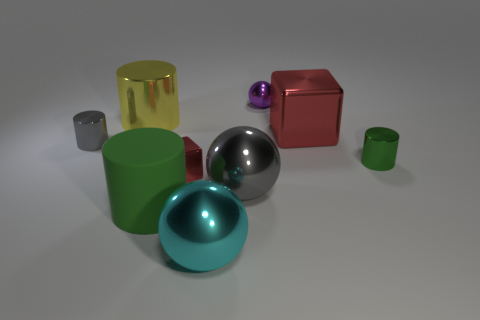Subtract all large metal balls. How many balls are left? 1 Subtract all cyan spheres. How many green cylinders are left? 2 Add 1 big things. How many objects exist? 10 Subtract all yellow cylinders. How many cylinders are left? 3 Subtract all cylinders. How many objects are left? 5 Subtract all green blocks. Subtract all gray cylinders. How many blocks are left? 2 Subtract all small green cylinders. Subtract all large red metallic blocks. How many objects are left? 7 Add 1 small gray shiny cylinders. How many small gray shiny cylinders are left? 2 Add 3 big metal spheres. How many big metal spheres exist? 5 Subtract 0 green balls. How many objects are left? 9 